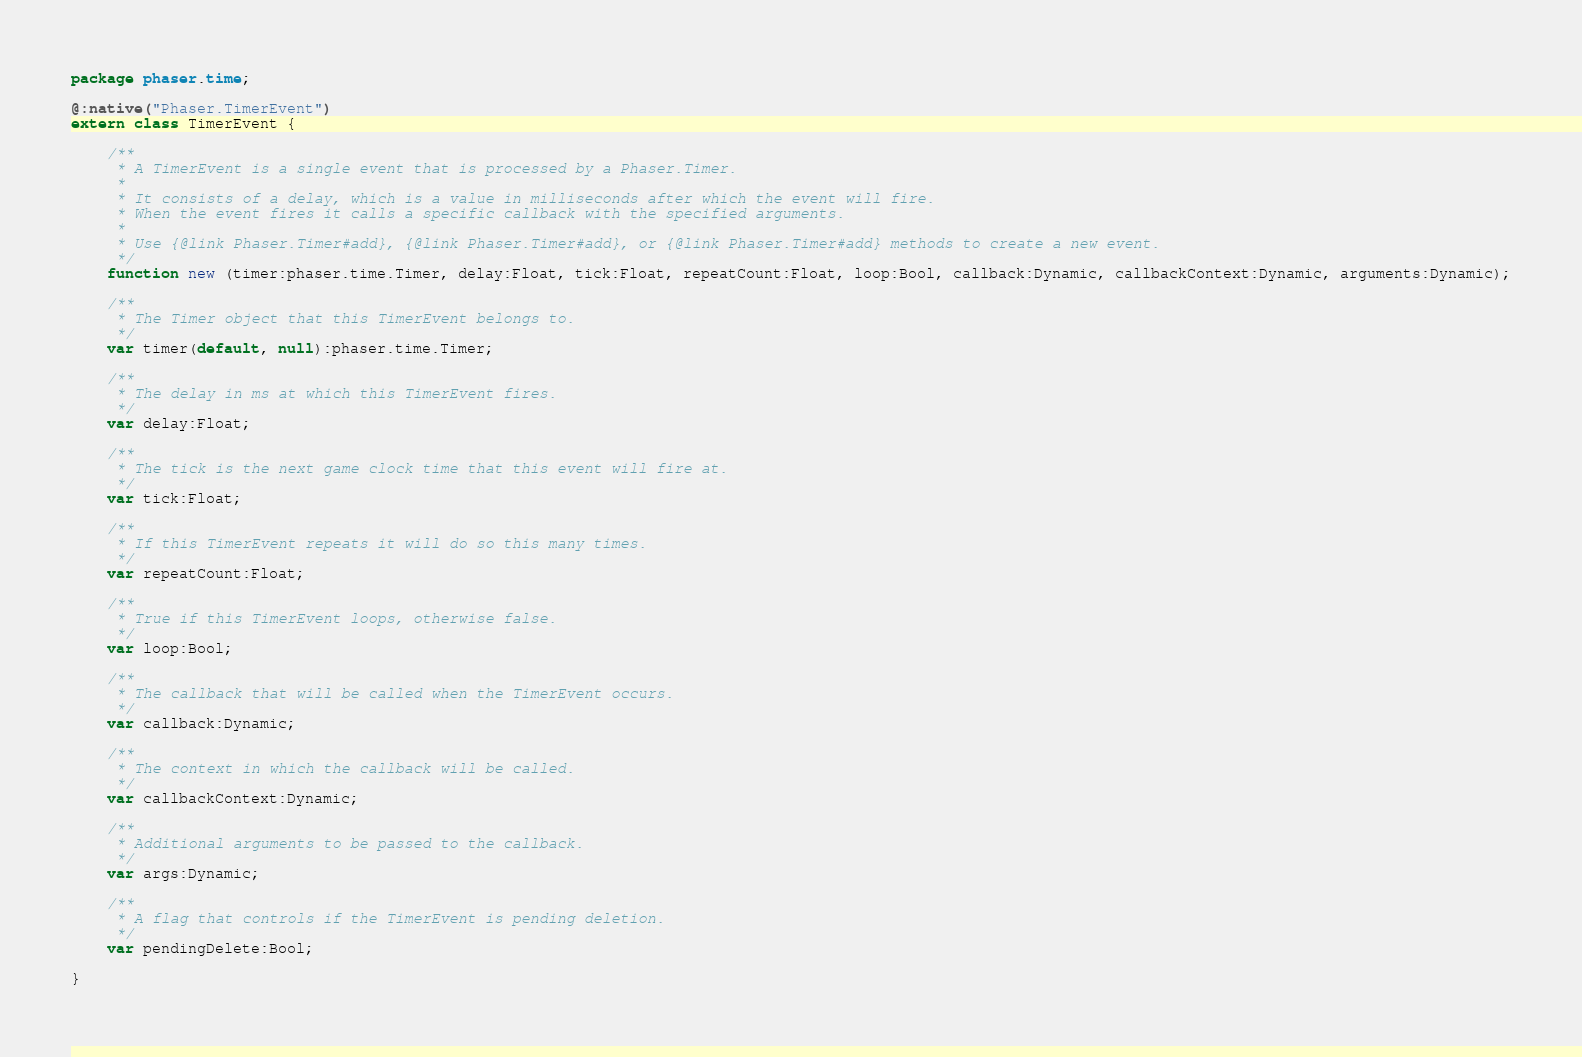Convert code to text. <code><loc_0><loc_0><loc_500><loc_500><_Haxe_>package phaser.time;

@:native("Phaser.TimerEvent")
extern class TimerEvent {
	
	/**
	 * A TimerEvent is a single event that is processed by a Phaser.Timer.
	 * 
	 * It consists of a delay, which is a value in milliseconds after which the event will fire.
	 * When the event fires it calls a specific callback with the specified arguments.
	 * 
	 * Use {@link Phaser.Timer#add}, {@link Phaser.Timer#add}, or {@link Phaser.Timer#add} methods to create a new event.
	 */
	function new (timer:phaser.time.Timer, delay:Float, tick:Float, repeatCount:Float, loop:Bool, callback:Dynamic, callbackContext:Dynamic, arguments:Dynamic);
	
	/**
	 * The Timer object that this TimerEvent belongs to.
	 */
	var timer(default, null):phaser.time.Timer;
	
	/**
	 * The delay in ms at which this TimerEvent fires.
	 */
	var delay:Float;
	
	/**
	 * The tick is the next game clock time that this event will fire at.
	 */
	var tick:Float;
	
	/**
	 * If this TimerEvent repeats it will do so this many times.
	 */
	var repeatCount:Float;
	
	/**
	 * True if this TimerEvent loops, otherwise false.
	 */
	var loop:Bool;
	
	/**
	 * The callback that will be called when the TimerEvent occurs.
	 */
	var callback:Dynamic;
	
	/**
	 * The context in which the callback will be called.
	 */
	var callbackContext:Dynamic;
	
	/**
	 * Additional arguments to be passed to the callback.
	 */
	var args:Dynamic;
	
	/**
	 * A flag that controls if the TimerEvent is pending deletion.
	 */
	var pendingDelete:Bool;
	
}
</code> 